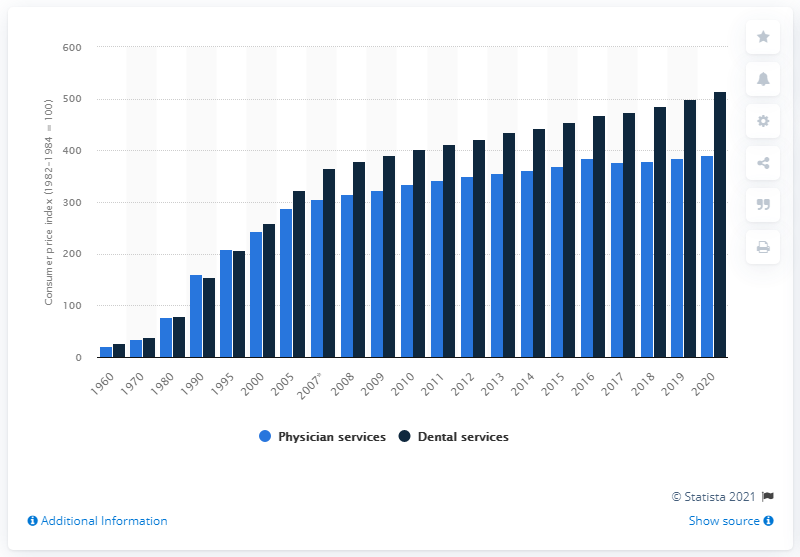Indicate a few pertinent items in this graphic. The CPI for dental services in 2020 was 391.8. 